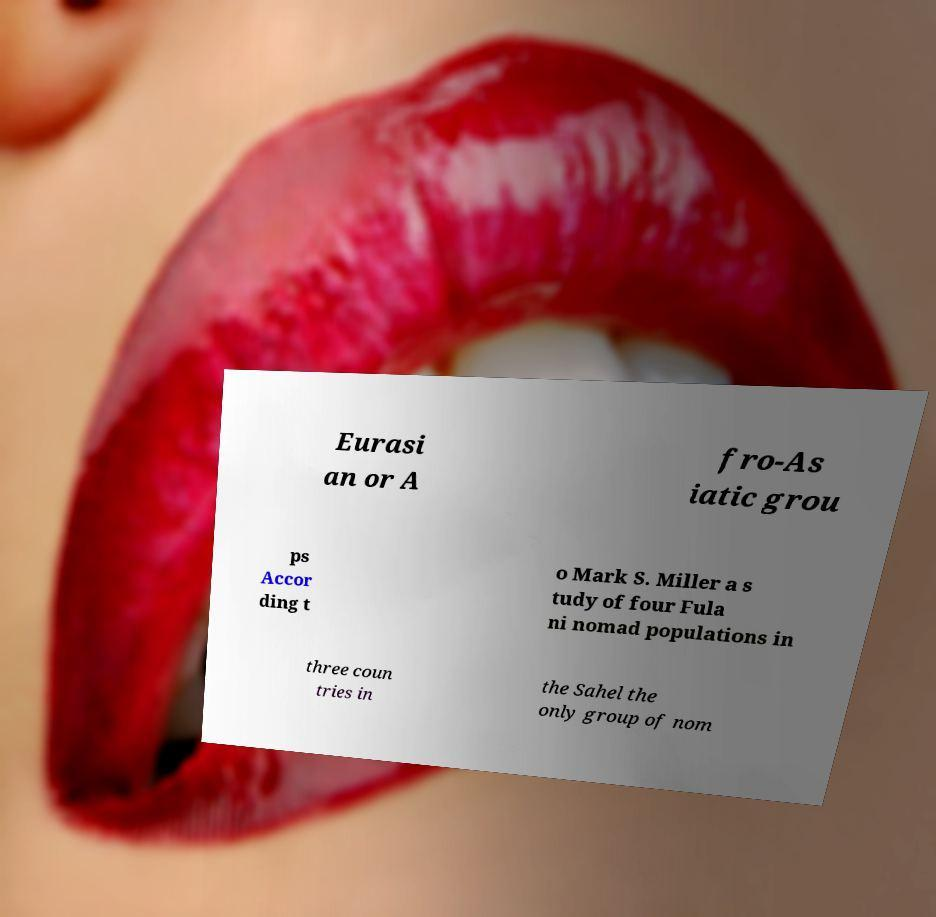There's text embedded in this image that I need extracted. Can you transcribe it verbatim? Eurasi an or A fro-As iatic grou ps Accor ding t o Mark S. Miller a s tudy of four Fula ni nomad populations in three coun tries in the Sahel the only group of nom 